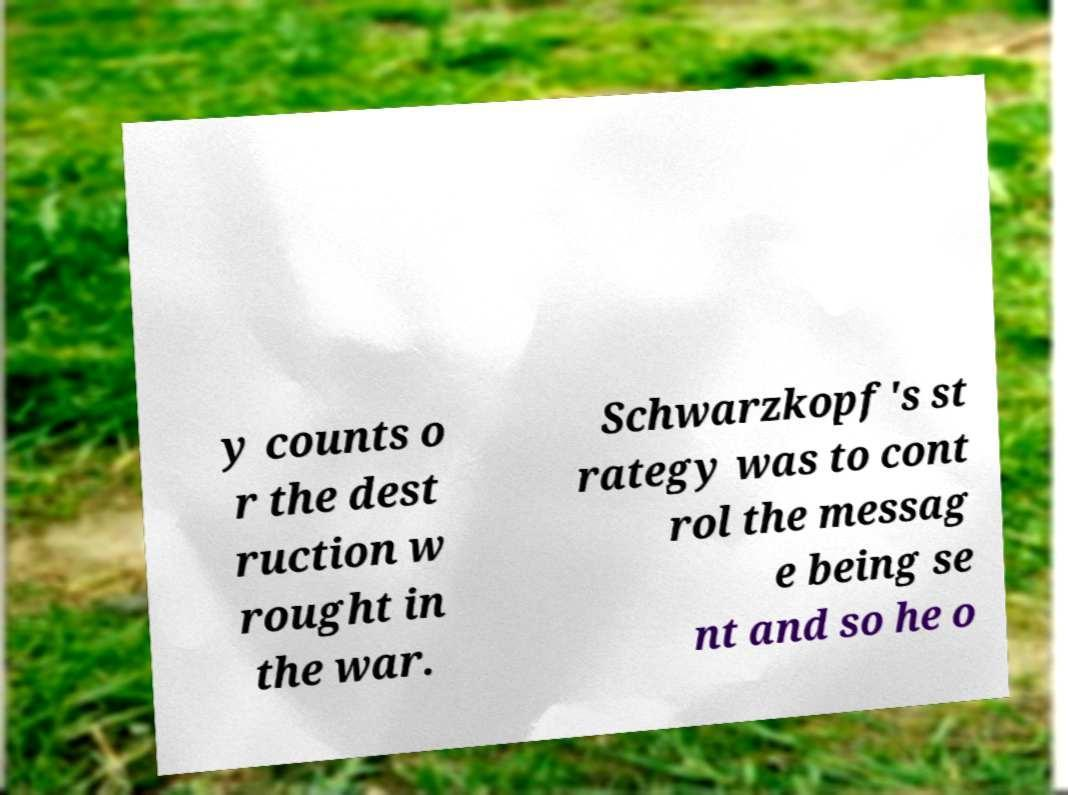I need the written content from this picture converted into text. Can you do that? y counts o r the dest ruction w rought in the war. Schwarzkopf's st rategy was to cont rol the messag e being se nt and so he o 